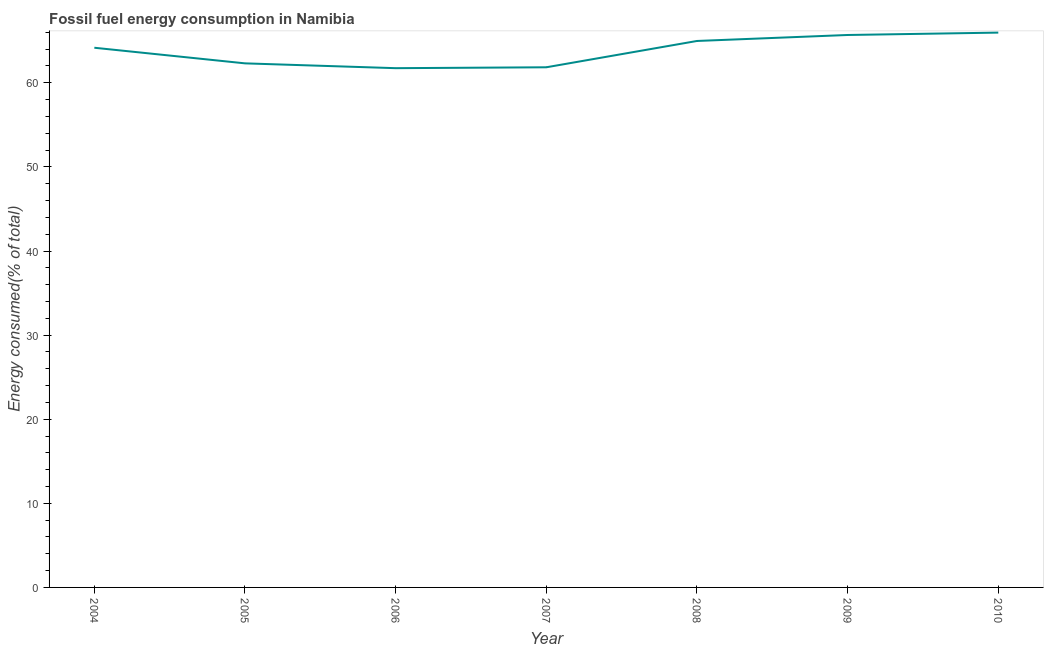What is the fossil fuel energy consumption in 2004?
Your answer should be compact. 64.17. Across all years, what is the maximum fossil fuel energy consumption?
Keep it short and to the point. 65.97. Across all years, what is the minimum fossil fuel energy consumption?
Offer a terse response. 61.74. In which year was the fossil fuel energy consumption maximum?
Ensure brevity in your answer.  2010. What is the sum of the fossil fuel energy consumption?
Your answer should be compact. 446.7. What is the difference between the fossil fuel energy consumption in 2009 and 2010?
Provide a succinct answer. -0.28. What is the average fossil fuel energy consumption per year?
Give a very brief answer. 63.81. What is the median fossil fuel energy consumption?
Give a very brief answer. 64.17. Do a majority of the years between 2010 and 2006 (inclusive) have fossil fuel energy consumption greater than 38 %?
Your answer should be very brief. Yes. What is the ratio of the fossil fuel energy consumption in 2007 to that in 2010?
Offer a terse response. 0.94. Is the fossil fuel energy consumption in 2004 less than that in 2009?
Ensure brevity in your answer.  Yes. What is the difference between the highest and the second highest fossil fuel energy consumption?
Your response must be concise. 0.28. What is the difference between the highest and the lowest fossil fuel energy consumption?
Provide a short and direct response. 4.23. In how many years, is the fossil fuel energy consumption greater than the average fossil fuel energy consumption taken over all years?
Your answer should be compact. 4. How many lines are there?
Offer a terse response. 1. How many years are there in the graph?
Ensure brevity in your answer.  7. What is the difference between two consecutive major ticks on the Y-axis?
Provide a short and direct response. 10. Does the graph contain any zero values?
Provide a short and direct response. No. Does the graph contain grids?
Your answer should be compact. No. What is the title of the graph?
Make the answer very short. Fossil fuel energy consumption in Namibia. What is the label or title of the Y-axis?
Your answer should be very brief. Energy consumed(% of total). What is the Energy consumed(% of total) of 2004?
Ensure brevity in your answer.  64.17. What is the Energy consumed(% of total) in 2005?
Your answer should be compact. 62.31. What is the Energy consumed(% of total) of 2006?
Your answer should be compact. 61.74. What is the Energy consumed(% of total) of 2007?
Your response must be concise. 61.85. What is the Energy consumed(% of total) in 2008?
Your answer should be compact. 64.97. What is the Energy consumed(% of total) of 2009?
Your response must be concise. 65.69. What is the Energy consumed(% of total) in 2010?
Offer a very short reply. 65.97. What is the difference between the Energy consumed(% of total) in 2004 and 2005?
Your answer should be very brief. 1.86. What is the difference between the Energy consumed(% of total) in 2004 and 2006?
Your response must be concise. 2.43. What is the difference between the Energy consumed(% of total) in 2004 and 2007?
Provide a short and direct response. 2.32. What is the difference between the Energy consumed(% of total) in 2004 and 2008?
Your response must be concise. -0.81. What is the difference between the Energy consumed(% of total) in 2004 and 2009?
Ensure brevity in your answer.  -1.52. What is the difference between the Energy consumed(% of total) in 2004 and 2010?
Ensure brevity in your answer.  -1.8. What is the difference between the Energy consumed(% of total) in 2005 and 2006?
Offer a terse response. 0.57. What is the difference between the Energy consumed(% of total) in 2005 and 2007?
Ensure brevity in your answer.  0.47. What is the difference between the Energy consumed(% of total) in 2005 and 2008?
Your response must be concise. -2.66. What is the difference between the Energy consumed(% of total) in 2005 and 2009?
Your answer should be very brief. -3.37. What is the difference between the Energy consumed(% of total) in 2005 and 2010?
Your answer should be very brief. -3.66. What is the difference between the Energy consumed(% of total) in 2006 and 2007?
Ensure brevity in your answer.  -0.11. What is the difference between the Energy consumed(% of total) in 2006 and 2008?
Make the answer very short. -3.24. What is the difference between the Energy consumed(% of total) in 2006 and 2009?
Offer a terse response. -3.95. What is the difference between the Energy consumed(% of total) in 2006 and 2010?
Offer a very short reply. -4.23. What is the difference between the Energy consumed(% of total) in 2007 and 2008?
Keep it short and to the point. -3.13. What is the difference between the Energy consumed(% of total) in 2007 and 2009?
Provide a short and direct response. -3.84. What is the difference between the Energy consumed(% of total) in 2007 and 2010?
Offer a very short reply. -4.12. What is the difference between the Energy consumed(% of total) in 2008 and 2009?
Your answer should be very brief. -0.71. What is the difference between the Energy consumed(% of total) in 2008 and 2010?
Provide a succinct answer. -0.99. What is the difference between the Energy consumed(% of total) in 2009 and 2010?
Ensure brevity in your answer.  -0.28. What is the ratio of the Energy consumed(% of total) in 2004 to that in 2005?
Your response must be concise. 1.03. What is the ratio of the Energy consumed(% of total) in 2004 to that in 2006?
Provide a succinct answer. 1.04. What is the ratio of the Energy consumed(% of total) in 2004 to that in 2007?
Provide a succinct answer. 1.04. What is the ratio of the Energy consumed(% of total) in 2004 to that in 2008?
Make the answer very short. 0.99. What is the ratio of the Energy consumed(% of total) in 2004 to that in 2009?
Your answer should be compact. 0.98. What is the ratio of the Energy consumed(% of total) in 2005 to that in 2006?
Your answer should be very brief. 1.01. What is the ratio of the Energy consumed(% of total) in 2005 to that in 2007?
Provide a succinct answer. 1.01. What is the ratio of the Energy consumed(% of total) in 2005 to that in 2009?
Give a very brief answer. 0.95. What is the ratio of the Energy consumed(% of total) in 2005 to that in 2010?
Offer a very short reply. 0.94. What is the ratio of the Energy consumed(% of total) in 2006 to that in 2008?
Give a very brief answer. 0.95. What is the ratio of the Energy consumed(% of total) in 2006 to that in 2010?
Your answer should be very brief. 0.94. What is the ratio of the Energy consumed(% of total) in 2007 to that in 2009?
Offer a terse response. 0.94. What is the ratio of the Energy consumed(% of total) in 2007 to that in 2010?
Provide a succinct answer. 0.94. What is the ratio of the Energy consumed(% of total) in 2008 to that in 2010?
Your answer should be compact. 0.98. What is the ratio of the Energy consumed(% of total) in 2009 to that in 2010?
Make the answer very short. 1. 